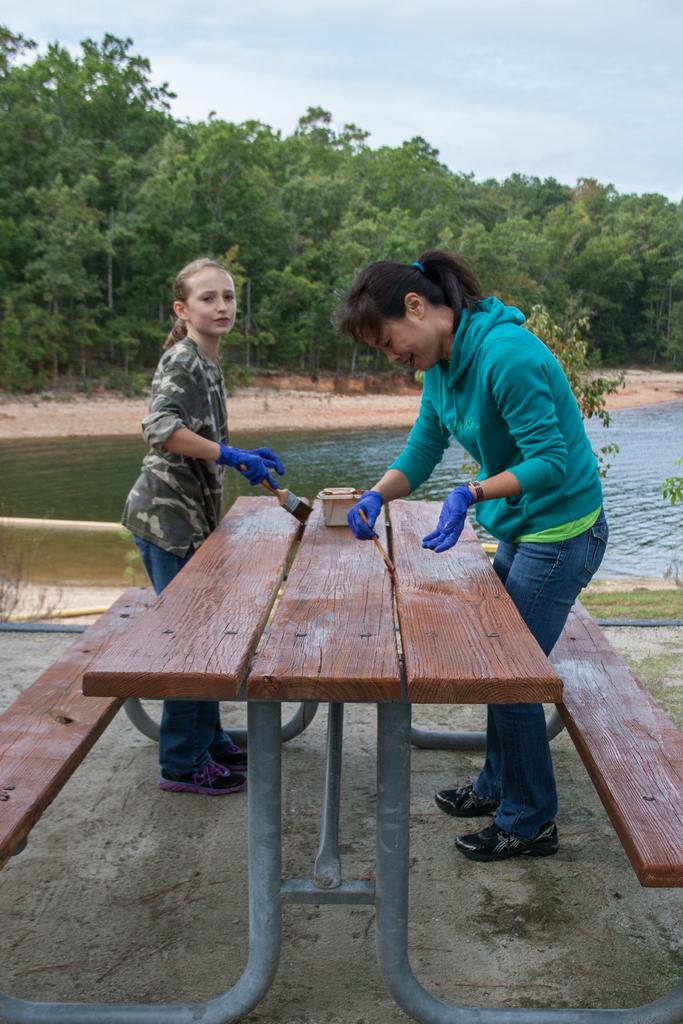Who is present in the image? There is a girl and a woman in the image. What are the girl and the woman holding? Both the girl and the woman are holding paint brushes. What can be seen in the background of the image? There is water, trees, and the sky visible in the background of the image. What is the girl and the woman sitting on? There is a bench in the image. What type of fruit is the girl holding in her hand in the image? There is no fruit present in the image; both the girl and the woman are holding paint brushes. Can you tell me how many mittens are visible in the image? There are no mittens present in the image. 